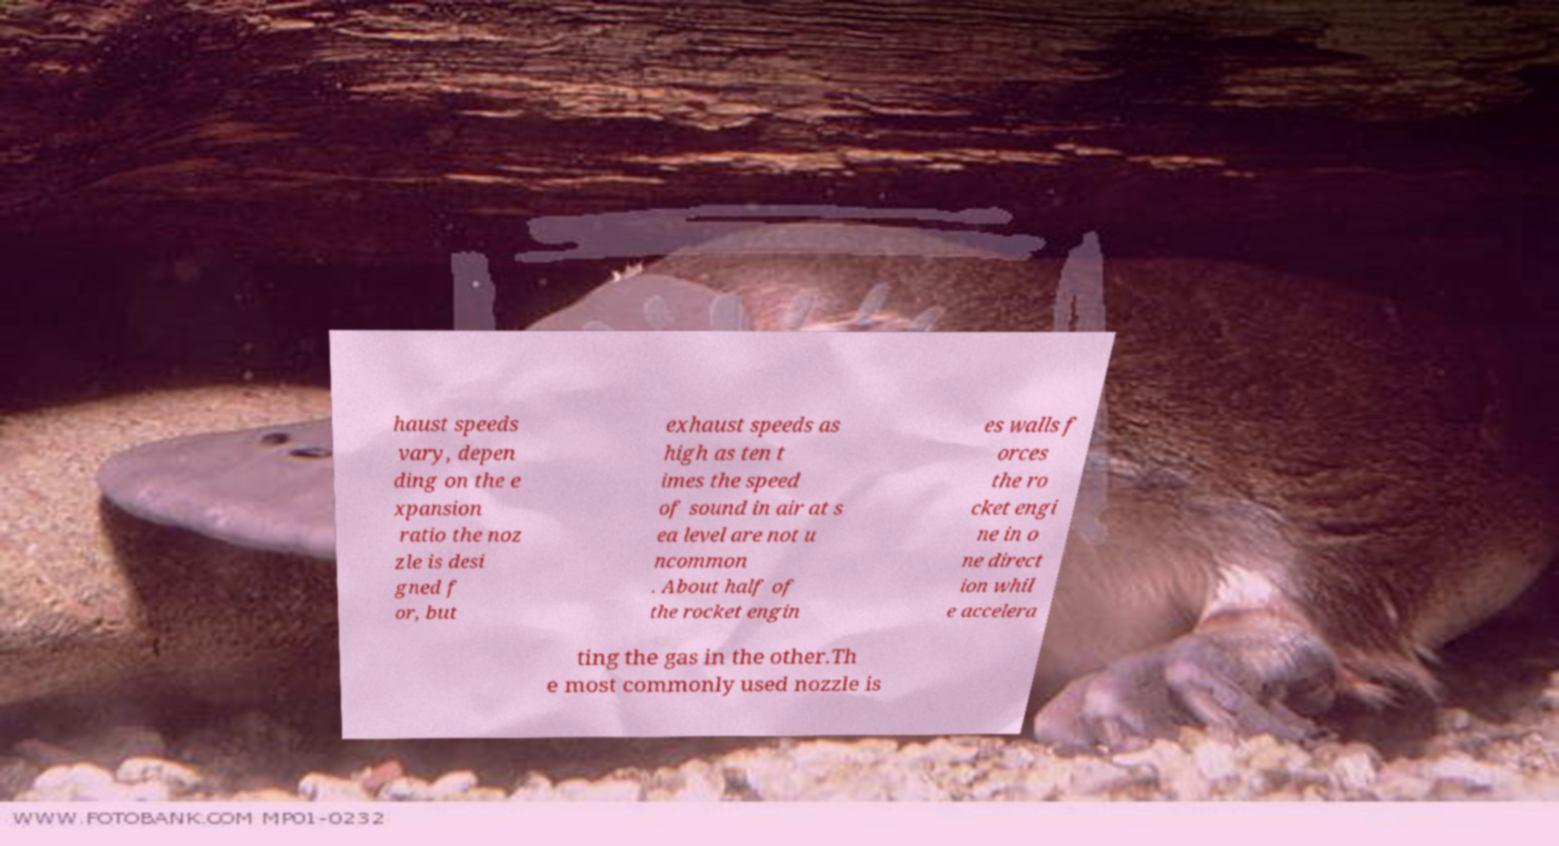What messages or text are displayed in this image? I need them in a readable, typed format. haust speeds vary, depen ding on the e xpansion ratio the noz zle is desi gned f or, but exhaust speeds as high as ten t imes the speed of sound in air at s ea level are not u ncommon . About half of the rocket engin es walls f orces the ro cket engi ne in o ne direct ion whil e accelera ting the gas in the other.Th e most commonly used nozzle is 